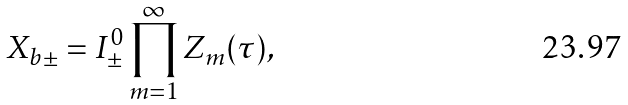<formula> <loc_0><loc_0><loc_500><loc_500>X _ { b \pm } = I ^ { 0 } _ { \pm } \prod _ { m = 1 } ^ { \infty } Z _ { m } ( \tau ) ,</formula> 